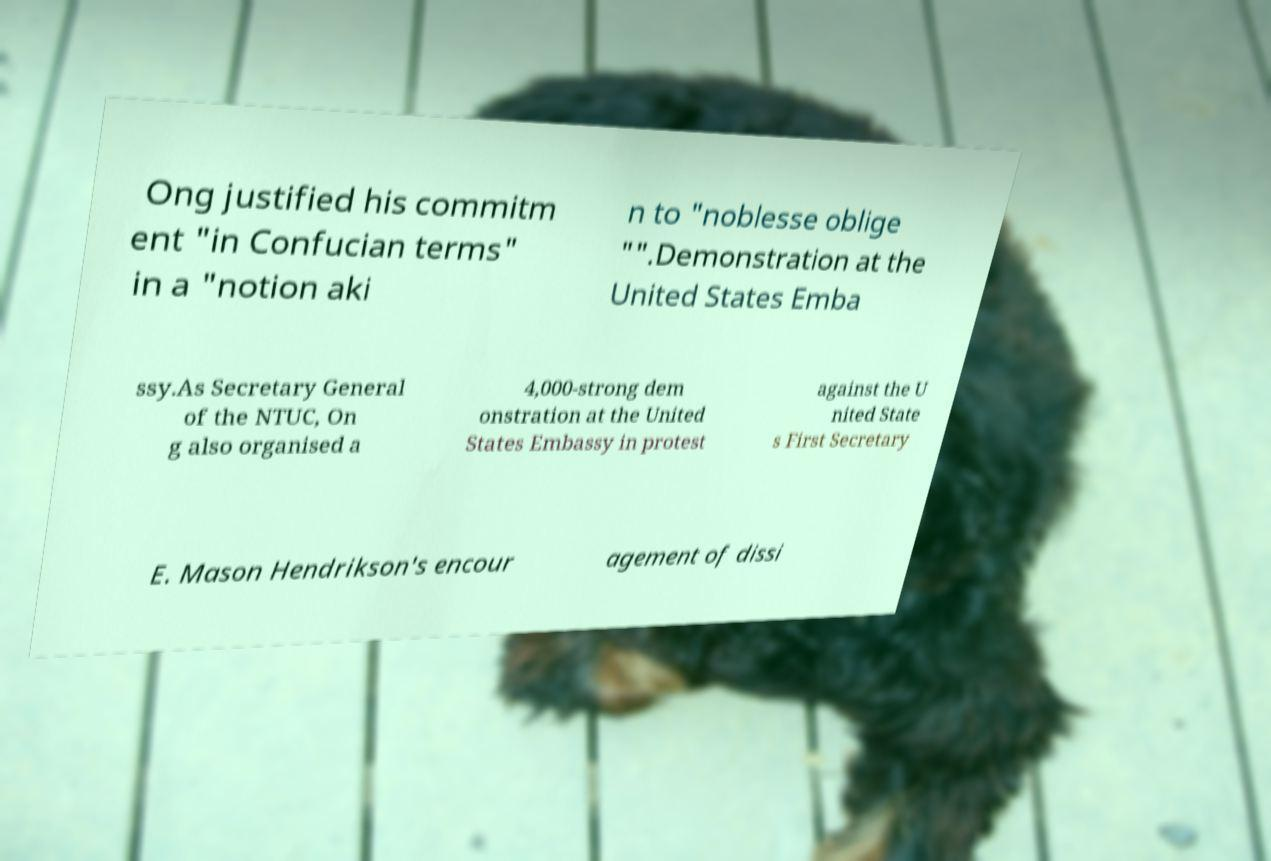Could you assist in decoding the text presented in this image and type it out clearly? Ong justified his commitm ent "in Confucian terms" in a "notion aki n to "noblesse oblige "".Demonstration at the United States Emba ssy.As Secretary General of the NTUC, On g also organised a 4,000-strong dem onstration at the United States Embassy in protest against the U nited State s First Secretary E. Mason Hendrikson's encour agement of dissi 